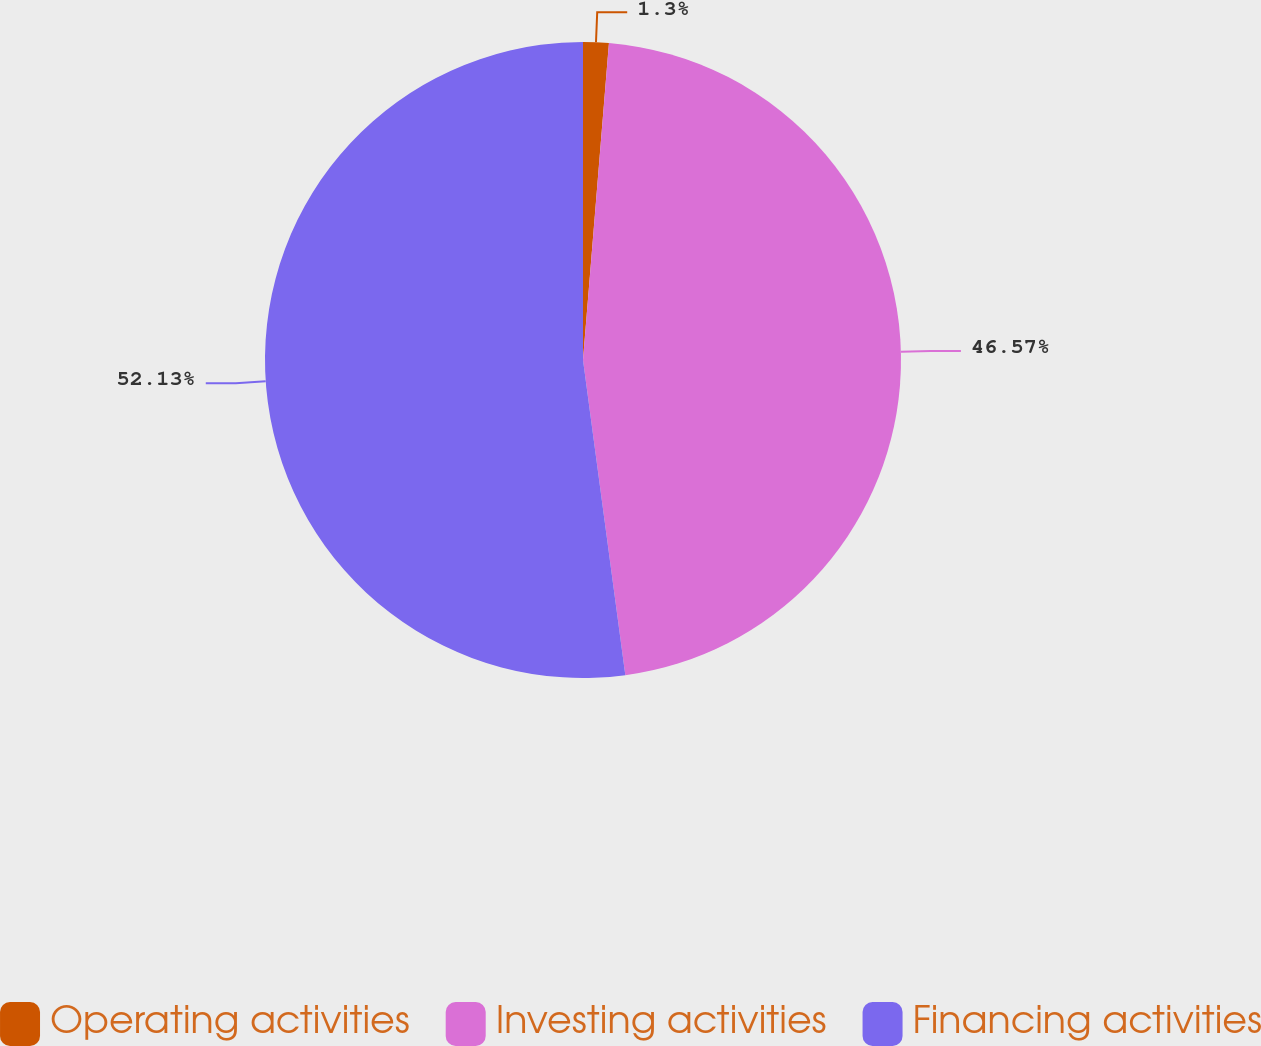Convert chart to OTSL. <chart><loc_0><loc_0><loc_500><loc_500><pie_chart><fcel>Operating activities<fcel>Investing activities<fcel>Financing activities<nl><fcel>1.3%<fcel>46.57%<fcel>52.12%<nl></chart> 